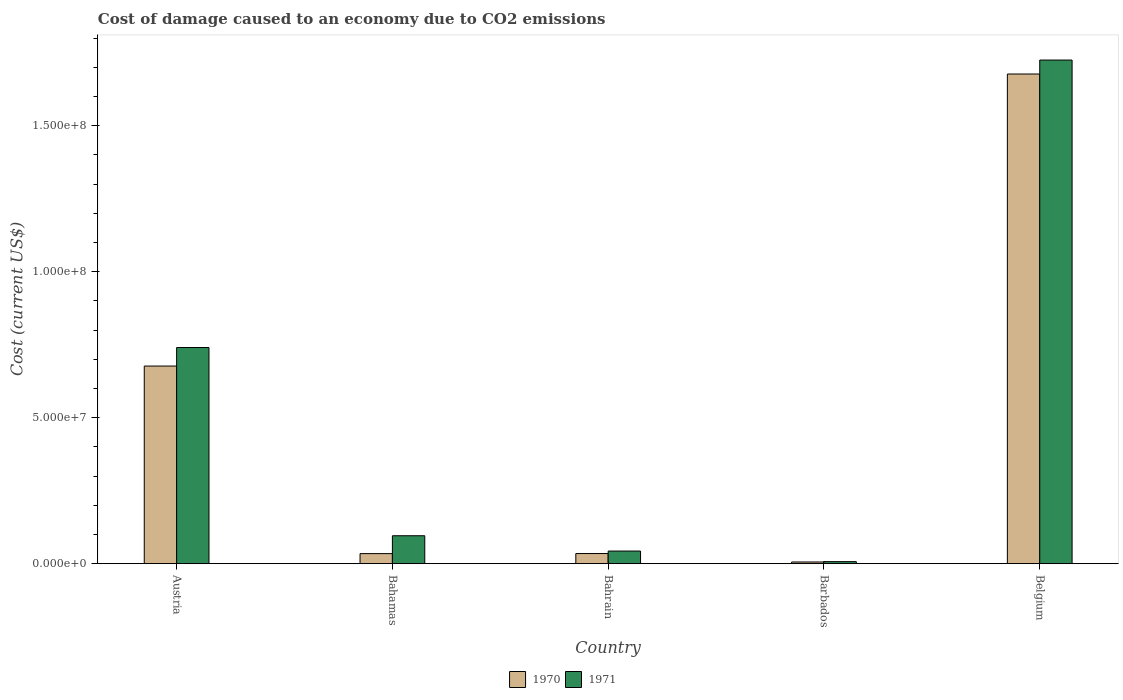How many different coloured bars are there?
Offer a very short reply. 2. Are the number of bars on each tick of the X-axis equal?
Give a very brief answer. Yes. How many bars are there on the 3rd tick from the right?
Ensure brevity in your answer.  2. What is the label of the 4th group of bars from the left?
Keep it short and to the point. Barbados. What is the cost of damage caused due to CO2 emissisons in 1970 in Austria?
Make the answer very short. 6.77e+07. Across all countries, what is the maximum cost of damage caused due to CO2 emissisons in 1970?
Give a very brief answer. 1.68e+08. Across all countries, what is the minimum cost of damage caused due to CO2 emissisons in 1971?
Provide a short and direct response. 6.87e+05. In which country was the cost of damage caused due to CO2 emissisons in 1970 maximum?
Provide a succinct answer. Belgium. In which country was the cost of damage caused due to CO2 emissisons in 1971 minimum?
Give a very brief answer. Barbados. What is the total cost of damage caused due to CO2 emissisons in 1971 in the graph?
Make the answer very short. 2.61e+08. What is the difference between the cost of damage caused due to CO2 emissisons in 1970 in Bahrain and that in Belgium?
Your answer should be very brief. -1.64e+08. What is the difference between the cost of damage caused due to CO2 emissisons in 1971 in Bahamas and the cost of damage caused due to CO2 emissisons in 1970 in Austria?
Your answer should be compact. -5.81e+07. What is the average cost of damage caused due to CO2 emissisons in 1970 per country?
Provide a short and direct response. 4.86e+07. What is the difference between the cost of damage caused due to CO2 emissisons of/in 1971 and cost of damage caused due to CO2 emissisons of/in 1970 in Bahrain?
Ensure brevity in your answer.  8.53e+05. In how many countries, is the cost of damage caused due to CO2 emissisons in 1970 greater than 140000000 US$?
Provide a succinct answer. 1. What is the ratio of the cost of damage caused due to CO2 emissisons in 1971 in Barbados to that in Belgium?
Make the answer very short. 0. Is the cost of damage caused due to CO2 emissisons in 1971 in Barbados less than that in Belgium?
Give a very brief answer. Yes. What is the difference between the highest and the second highest cost of damage caused due to CO2 emissisons in 1971?
Offer a terse response. -6.45e+07. What is the difference between the highest and the lowest cost of damage caused due to CO2 emissisons in 1970?
Give a very brief answer. 1.67e+08. Is the sum of the cost of damage caused due to CO2 emissisons in 1970 in Bahamas and Belgium greater than the maximum cost of damage caused due to CO2 emissisons in 1971 across all countries?
Keep it short and to the point. No. What does the 2nd bar from the left in Bahrain represents?
Make the answer very short. 1971. Are all the bars in the graph horizontal?
Provide a short and direct response. No. What is the difference between two consecutive major ticks on the Y-axis?
Your answer should be compact. 5.00e+07. Are the values on the major ticks of Y-axis written in scientific E-notation?
Offer a terse response. Yes. Does the graph contain any zero values?
Ensure brevity in your answer.  No. Does the graph contain grids?
Give a very brief answer. No. How many legend labels are there?
Provide a short and direct response. 2. What is the title of the graph?
Your answer should be compact. Cost of damage caused to an economy due to CO2 emissions. What is the label or title of the X-axis?
Keep it short and to the point. Country. What is the label or title of the Y-axis?
Your answer should be very brief. Cost (current US$). What is the Cost (current US$) in 1970 in Austria?
Offer a terse response. 6.77e+07. What is the Cost (current US$) of 1971 in Austria?
Offer a terse response. 7.40e+07. What is the Cost (current US$) in 1970 in Bahamas?
Your answer should be very brief. 3.44e+06. What is the Cost (current US$) of 1971 in Bahamas?
Provide a succinct answer. 9.55e+06. What is the Cost (current US$) in 1970 in Bahrain?
Ensure brevity in your answer.  3.46e+06. What is the Cost (current US$) in 1971 in Bahrain?
Offer a very short reply. 4.31e+06. What is the Cost (current US$) of 1970 in Barbados?
Your response must be concise. 5.73e+05. What is the Cost (current US$) in 1971 in Barbados?
Make the answer very short. 6.87e+05. What is the Cost (current US$) in 1970 in Belgium?
Your response must be concise. 1.68e+08. What is the Cost (current US$) of 1971 in Belgium?
Ensure brevity in your answer.  1.72e+08. Across all countries, what is the maximum Cost (current US$) of 1970?
Provide a succinct answer. 1.68e+08. Across all countries, what is the maximum Cost (current US$) of 1971?
Provide a short and direct response. 1.72e+08. Across all countries, what is the minimum Cost (current US$) in 1970?
Give a very brief answer. 5.73e+05. Across all countries, what is the minimum Cost (current US$) in 1971?
Ensure brevity in your answer.  6.87e+05. What is the total Cost (current US$) in 1970 in the graph?
Your answer should be compact. 2.43e+08. What is the total Cost (current US$) of 1971 in the graph?
Ensure brevity in your answer.  2.61e+08. What is the difference between the Cost (current US$) in 1970 in Austria and that in Bahamas?
Provide a succinct answer. 6.42e+07. What is the difference between the Cost (current US$) of 1971 in Austria and that in Bahamas?
Your answer should be compact. 6.45e+07. What is the difference between the Cost (current US$) of 1970 in Austria and that in Bahrain?
Ensure brevity in your answer.  6.42e+07. What is the difference between the Cost (current US$) in 1971 in Austria and that in Bahrain?
Give a very brief answer. 6.97e+07. What is the difference between the Cost (current US$) in 1970 in Austria and that in Barbados?
Offer a very short reply. 6.71e+07. What is the difference between the Cost (current US$) in 1971 in Austria and that in Barbados?
Make the answer very short. 7.33e+07. What is the difference between the Cost (current US$) of 1970 in Austria and that in Belgium?
Keep it short and to the point. -1.00e+08. What is the difference between the Cost (current US$) of 1971 in Austria and that in Belgium?
Your answer should be compact. -9.84e+07. What is the difference between the Cost (current US$) of 1970 in Bahamas and that in Bahrain?
Keep it short and to the point. -2.45e+04. What is the difference between the Cost (current US$) of 1971 in Bahamas and that in Bahrain?
Make the answer very short. 5.24e+06. What is the difference between the Cost (current US$) in 1970 in Bahamas and that in Barbados?
Provide a succinct answer. 2.86e+06. What is the difference between the Cost (current US$) of 1971 in Bahamas and that in Barbados?
Give a very brief answer. 8.87e+06. What is the difference between the Cost (current US$) of 1970 in Bahamas and that in Belgium?
Your answer should be very brief. -1.64e+08. What is the difference between the Cost (current US$) in 1971 in Bahamas and that in Belgium?
Offer a terse response. -1.63e+08. What is the difference between the Cost (current US$) in 1970 in Bahrain and that in Barbados?
Keep it short and to the point. 2.89e+06. What is the difference between the Cost (current US$) in 1971 in Bahrain and that in Barbados?
Ensure brevity in your answer.  3.63e+06. What is the difference between the Cost (current US$) of 1970 in Bahrain and that in Belgium?
Ensure brevity in your answer.  -1.64e+08. What is the difference between the Cost (current US$) in 1971 in Bahrain and that in Belgium?
Provide a short and direct response. -1.68e+08. What is the difference between the Cost (current US$) of 1970 in Barbados and that in Belgium?
Keep it short and to the point. -1.67e+08. What is the difference between the Cost (current US$) in 1971 in Barbados and that in Belgium?
Make the answer very short. -1.72e+08. What is the difference between the Cost (current US$) of 1970 in Austria and the Cost (current US$) of 1971 in Bahamas?
Your response must be concise. 5.81e+07. What is the difference between the Cost (current US$) of 1970 in Austria and the Cost (current US$) of 1971 in Bahrain?
Provide a short and direct response. 6.34e+07. What is the difference between the Cost (current US$) in 1970 in Austria and the Cost (current US$) in 1971 in Barbados?
Provide a succinct answer. 6.70e+07. What is the difference between the Cost (current US$) in 1970 in Austria and the Cost (current US$) in 1971 in Belgium?
Make the answer very short. -1.05e+08. What is the difference between the Cost (current US$) of 1970 in Bahamas and the Cost (current US$) of 1971 in Bahrain?
Provide a short and direct response. -8.78e+05. What is the difference between the Cost (current US$) in 1970 in Bahamas and the Cost (current US$) in 1971 in Barbados?
Make the answer very short. 2.75e+06. What is the difference between the Cost (current US$) of 1970 in Bahamas and the Cost (current US$) of 1971 in Belgium?
Offer a very short reply. -1.69e+08. What is the difference between the Cost (current US$) in 1970 in Bahrain and the Cost (current US$) in 1971 in Barbados?
Your answer should be compact. 2.77e+06. What is the difference between the Cost (current US$) in 1970 in Bahrain and the Cost (current US$) in 1971 in Belgium?
Your response must be concise. -1.69e+08. What is the difference between the Cost (current US$) in 1970 in Barbados and the Cost (current US$) in 1971 in Belgium?
Your answer should be compact. -1.72e+08. What is the average Cost (current US$) of 1970 per country?
Make the answer very short. 4.86e+07. What is the average Cost (current US$) in 1971 per country?
Your answer should be very brief. 5.22e+07. What is the difference between the Cost (current US$) of 1970 and Cost (current US$) of 1971 in Austria?
Provide a succinct answer. -6.35e+06. What is the difference between the Cost (current US$) in 1970 and Cost (current US$) in 1971 in Bahamas?
Make the answer very short. -6.12e+06. What is the difference between the Cost (current US$) of 1970 and Cost (current US$) of 1971 in Bahrain?
Your answer should be very brief. -8.53e+05. What is the difference between the Cost (current US$) in 1970 and Cost (current US$) in 1971 in Barbados?
Give a very brief answer. -1.14e+05. What is the difference between the Cost (current US$) in 1970 and Cost (current US$) in 1971 in Belgium?
Your response must be concise. -4.78e+06. What is the ratio of the Cost (current US$) of 1970 in Austria to that in Bahamas?
Provide a succinct answer. 19.69. What is the ratio of the Cost (current US$) of 1971 in Austria to that in Bahamas?
Provide a succinct answer. 7.75. What is the ratio of the Cost (current US$) in 1970 in Austria to that in Bahrain?
Provide a succinct answer. 19.55. What is the ratio of the Cost (current US$) of 1971 in Austria to that in Bahrain?
Ensure brevity in your answer.  17.16. What is the ratio of the Cost (current US$) of 1970 in Austria to that in Barbados?
Keep it short and to the point. 118.15. What is the ratio of the Cost (current US$) of 1971 in Austria to that in Barbados?
Offer a very short reply. 107.75. What is the ratio of the Cost (current US$) of 1970 in Austria to that in Belgium?
Offer a terse response. 0.4. What is the ratio of the Cost (current US$) in 1971 in Austria to that in Belgium?
Offer a terse response. 0.43. What is the ratio of the Cost (current US$) in 1971 in Bahamas to that in Bahrain?
Provide a short and direct response. 2.21. What is the ratio of the Cost (current US$) in 1971 in Bahamas to that in Barbados?
Offer a terse response. 13.91. What is the ratio of the Cost (current US$) in 1970 in Bahamas to that in Belgium?
Offer a terse response. 0.02. What is the ratio of the Cost (current US$) of 1971 in Bahamas to that in Belgium?
Your answer should be compact. 0.06. What is the ratio of the Cost (current US$) of 1970 in Bahrain to that in Barbados?
Keep it short and to the point. 6.04. What is the ratio of the Cost (current US$) of 1971 in Bahrain to that in Barbados?
Offer a very short reply. 6.28. What is the ratio of the Cost (current US$) of 1970 in Bahrain to that in Belgium?
Your response must be concise. 0.02. What is the ratio of the Cost (current US$) in 1971 in Bahrain to that in Belgium?
Offer a very short reply. 0.03. What is the ratio of the Cost (current US$) of 1970 in Barbados to that in Belgium?
Keep it short and to the point. 0. What is the ratio of the Cost (current US$) of 1971 in Barbados to that in Belgium?
Make the answer very short. 0. What is the difference between the highest and the second highest Cost (current US$) in 1970?
Provide a succinct answer. 1.00e+08. What is the difference between the highest and the second highest Cost (current US$) in 1971?
Your answer should be compact. 9.84e+07. What is the difference between the highest and the lowest Cost (current US$) in 1970?
Provide a succinct answer. 1.67e+08. What is the difference between the highest and the lowest Cost (current US$) in 1971?
Keep it short and to the point. 1.72e+08. 